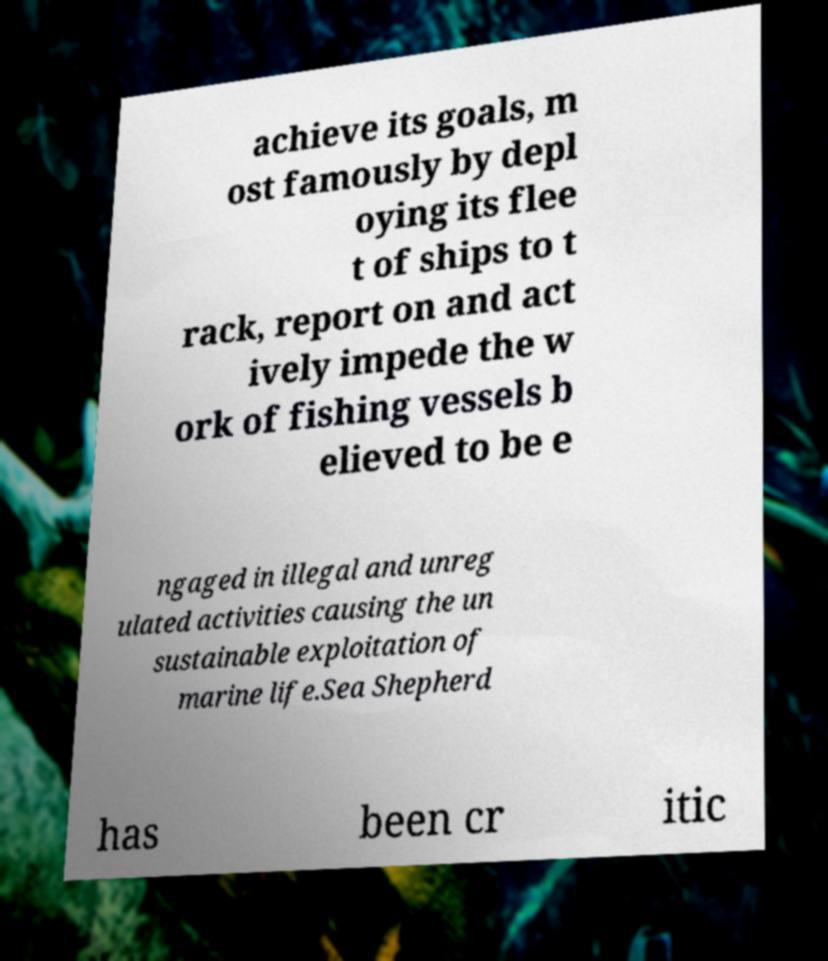Can you read and provide the text displayed in the image?This photo seems to have some interesting text. Can you extract and type it out for me? achieve its goals, m ost famously by depl oying its flee t of ships to t rack, report on and act ively impede the w ork of fishing vessels b elieved to be e ngaged in illegal and unreg ulated activities causing the un sustainable exploitation of marine life.Sea Shepherd has been cr itic 